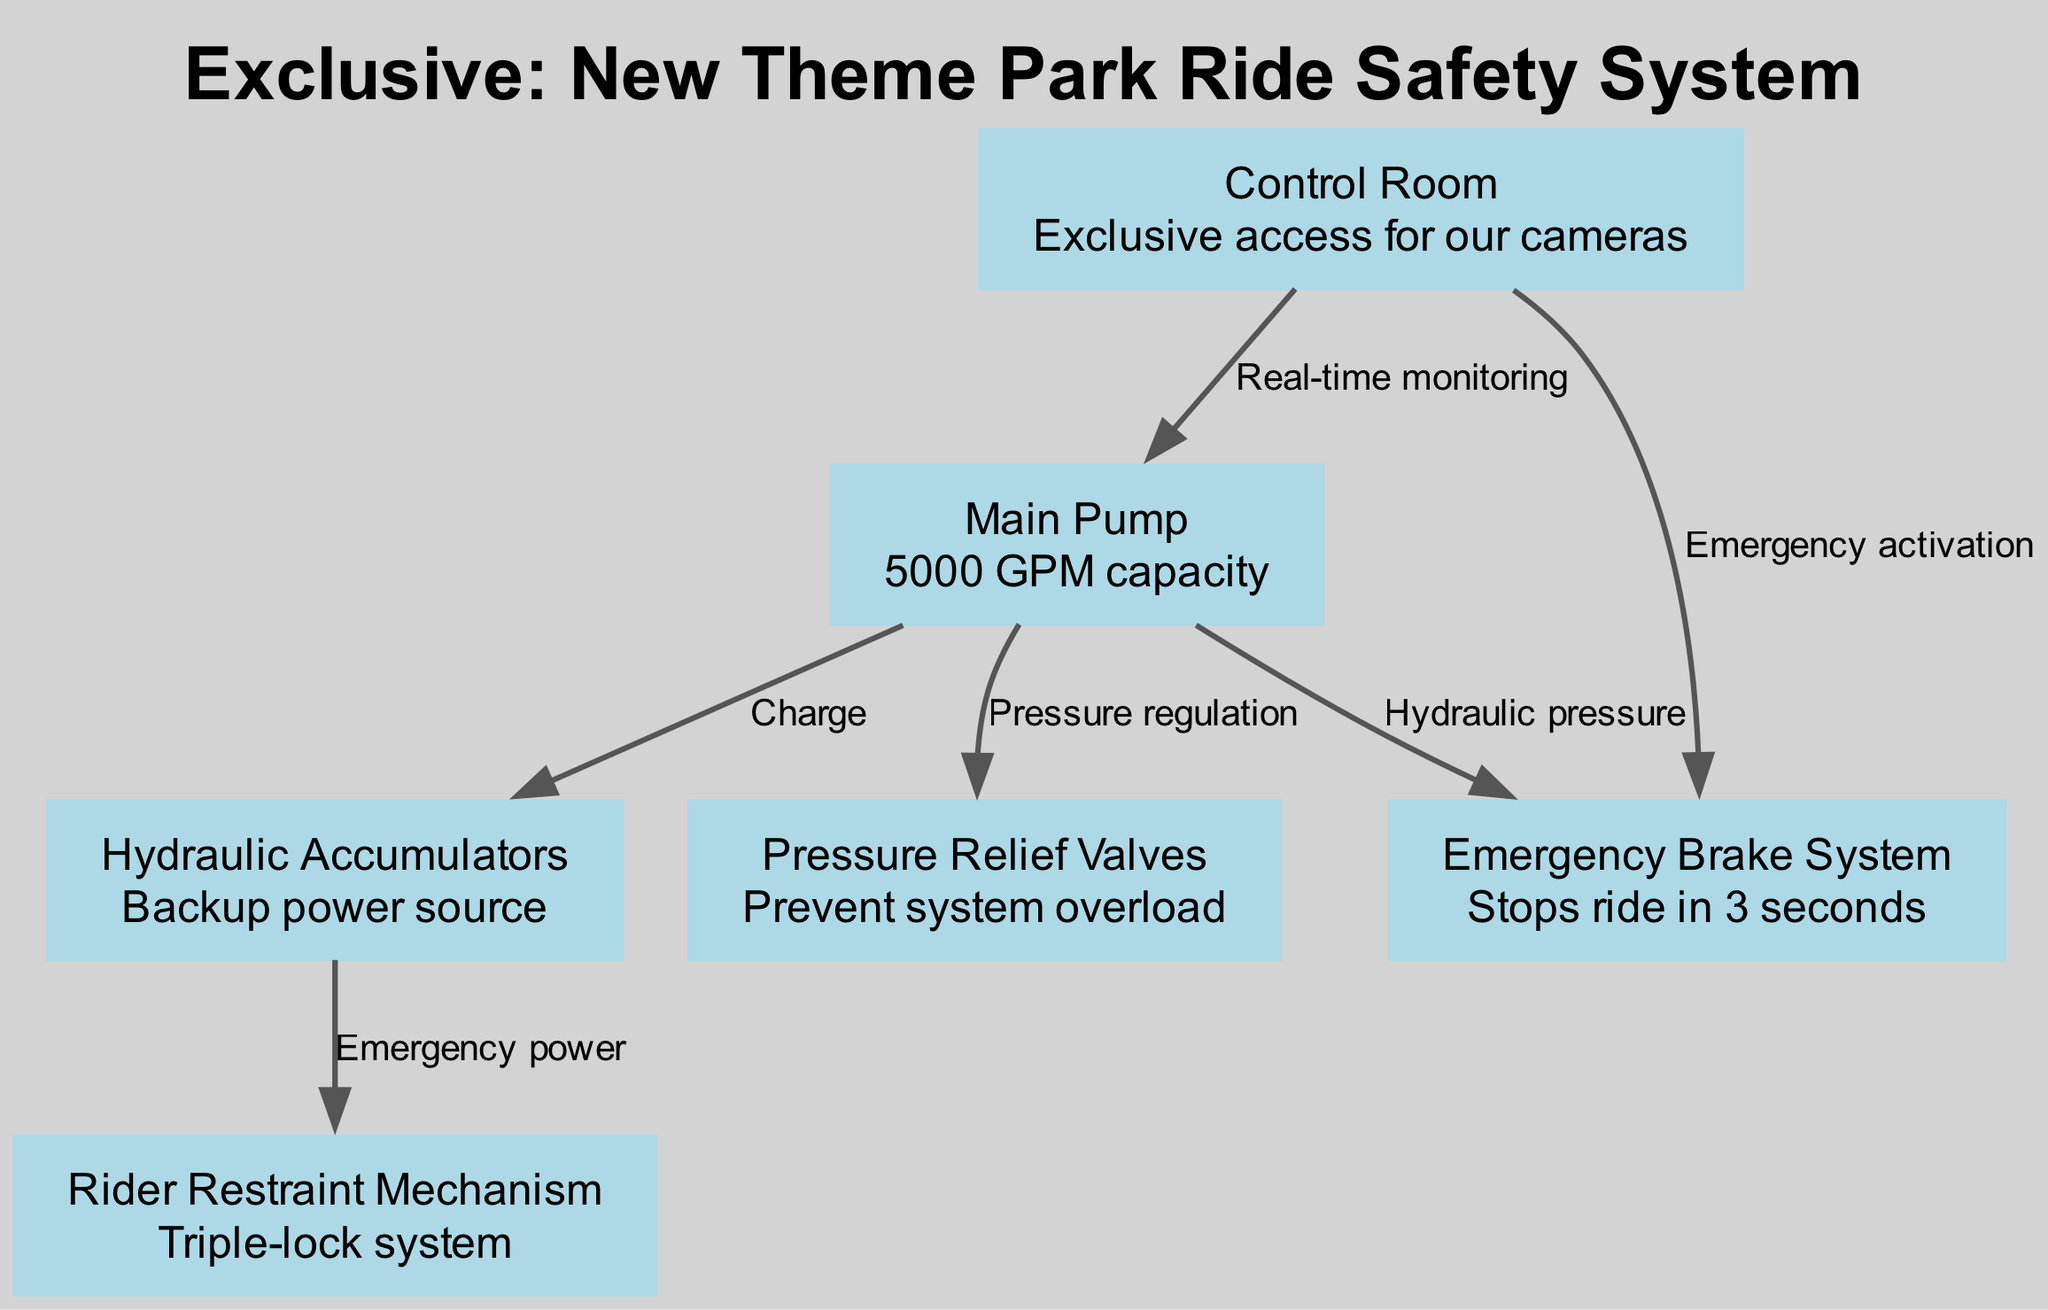What is the capacity of the Main Pump? The capacity of the Main Pump is specified as "5000 GPM" in the description of that node in the diagram.
Answer: 5000 GPM How many nodes are in the diagram? The diagram includes a list of nodes: Control Room, Main Pump, Emergency Brake System, Hydraulic Accumulators, Pressure Relief Valves, and Rider Restraint Mechanism, making a total of 6 nodes.
Answer: 6 What does the edge from Control Room to Main Pump represent? The edge connecting Control Room to Main Pump is labeled "Real-time monitoring," indicating the relationship between the two nodes regarding observing or managing the pump's operation.
Answer: Real-time monitoring What safety mechanism stops the ride in seconds? The Emergency Brake System is described as being able to stop the ride in "3 seconds," as indicated in its description.
Answer: 3 seconds Which node provides backup power? The Hydraulic Accumulators are described as a "Backup power source" in their respective node's description, indicating their role in the system.
Answer: Backup power source How does the Hydraulic Accumulators affect the Rider Restraint Mechanism? The edge linking Hydraulic Accumulators to Rider Restraint Mechanism is labeled "Emergency power," suggesting that in case of a power failure, the accumulators can fund the power required for the restraint mechanism to function.
Answer: Emergency power Which system prevents the hydraulic system from overload? The Pressure Relief Valves are mentioned as being designed to "Prevent system overload," indicating their crucial role in ensuring the safety of the hydraulic system.
Answer: Prevent system overload What is the function of the edge between Main Pump and Emergency Brake System? The edge labeled "Hydraulic pressure" connects the Main Pump to the Emergency Brake System, indicating that the operation of the brake system relies on the hydraulic pressure produced by the Main Pump.
Answer: Hydraulic pressure How does the Control Room interact with the Emergency Brake System? The edge linking the Control Room to the Emergency Brake System is labeled "Emergency activation," illustrating that the Control Room provides the activation signal in emergency situations for the brake system to function.
Answer: Emergency activation 